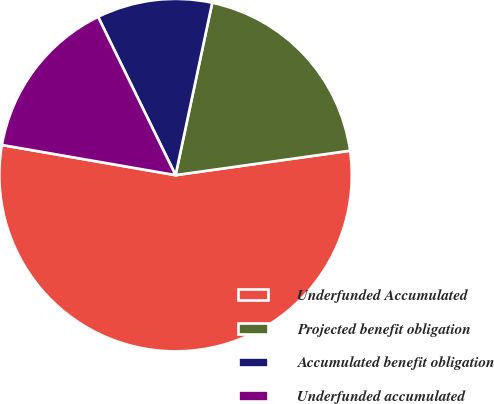Convert chart. <chart><loc_0><loc_0><loc_500><loc_500><pie_chart><fcel>Underfunded Accumulated<fcel>Projected benefit obligation<fcel>Accumulated benefit obligation<fcel>Underfunded accumulated<nl><fcel>54.95%<fcel>19.45%<fcel>10.58%<fcel>15.02%<nl></chart> 